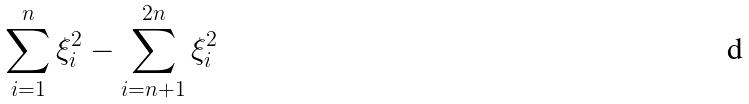Convert formula to latex. <formula><loc_0><loc_0><loc_500><loc_500>\sum _ { i = 1 } ^ { n } \xi _ { i } ^ { 2 } - \sum _ { i = n + 1 } ^ { 2 n } \xi _ { i } ^ { 2 }</formula> 